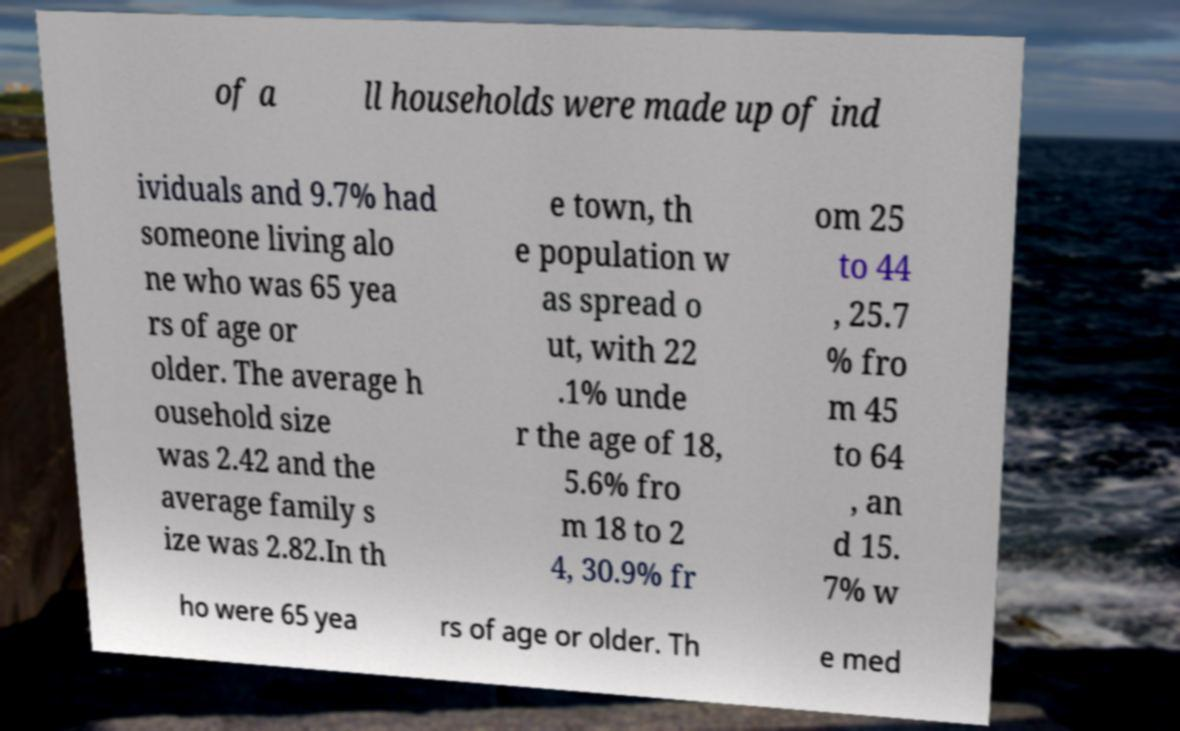Could you assist in decoding the text presented in this image and type it out clearly? of a ll households were made up of ind ividuals and 9.7% had someone living alo ne who was 65 yea rs of age or older. The average h ousehold size was 2.42 and the average family s ize was 2.82.In th e town, th e population w as spread o ut, with 22 .1% unde r the age of 18, 5.6% fro m 18 to 2 4, 30.9% fr om 25 to 44 , 25.7 % fro m 45 to 64 , an d 15. 7% w ho were 65 yea rs of age or older. Th e med 